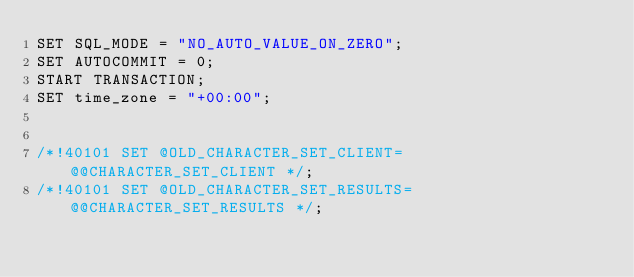<code> <loc_0><loc_0><loc_500><loc_500><_SQL_>SET SQL_MODE = "NO_AUTO_VALUE_ON_ZERO";
SET AUTOCOMMIT = 0;
START TRANSACTION;
SET time_zone = "+00:00";


/*!40101 SET @OLD_CHARACTER_SET_CLIENT=@@CHARACTER_SET_CLIENT */;
/*!40101 SET @OLD_CHARACTER_SET_RESULTS=@@CHARACTER_SET_RESULTS */;</code> 